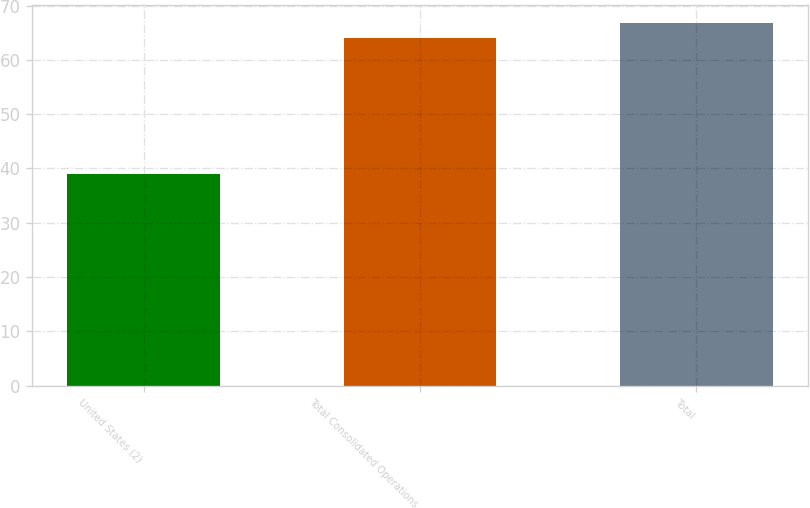Convert chart. <chart><loc_0><loc_0><loc_500><loc_500><bar_chart><fcel>United States (2)<fcel>Total Consolidated Operations<fcel>Total<nl><fcel>39<fcel>64<fcel>66.7<nl></chart> 